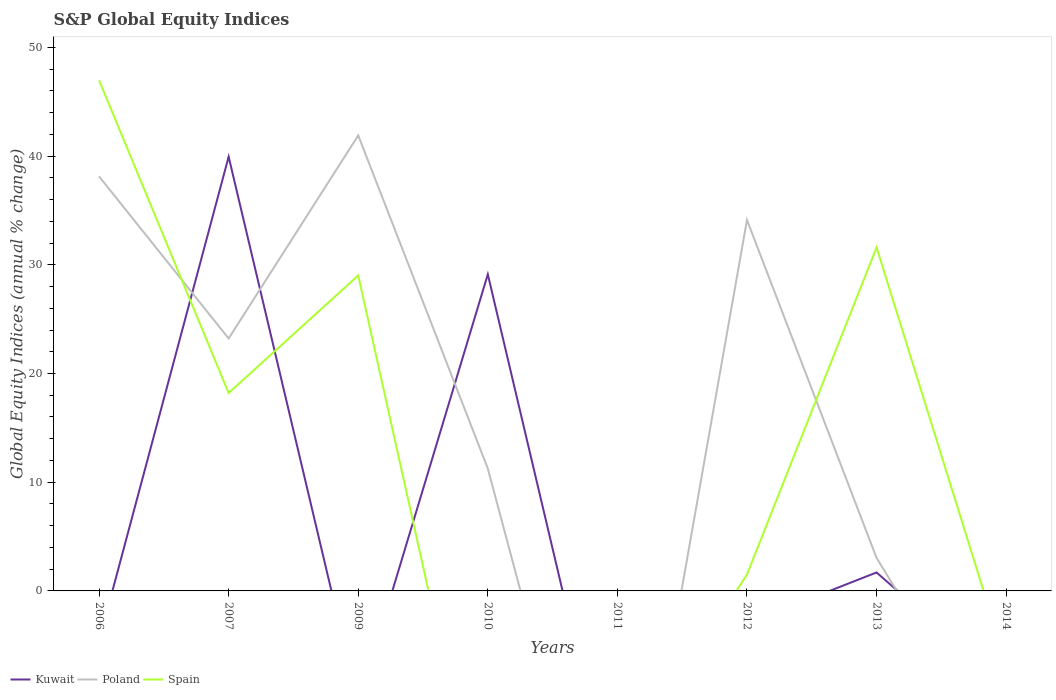Does the line corresponding to Spain intersect with the line corresponding to Poland?
Provide a succinct answer. Yes. What is the total global equity indices in Kuwait in the graph?
Your answer should be very brief. 38.24. What is the difference between the highest and the second highest global equity indices in Spain?
Offer a terse response. 46.98. What is the difference between the highest and the lowest global equity indices in Spain?
Ensure brevity in your answer.  4. Is the global equity indices in Spain strictly greater than the global equity indices in Poland over the years?
Offer a terse response. No. How many lines are there?
Offer a terse response. 3. How many years are there in the graph?
Make the answer very short. 8. Are the values on the major ticks of Y-axis written in scientific E-notation?
Make the answer very short. No. Does the graph contain any zero values?
Your answer should be compact. Yes. What is the title of the graph?
Keep it short and to the point. S&P Global Equity Indices. Does "Latin America(developing only)" appear as one of the legend labels in the graph?
Make the answer very short. No. What is the label or title of the X-axis?
Offer a terse response. Years. What is the label or title of the Y-axis?
Offer a very short reply. Global Equity Indices (annual % change). What is the Global Equity Indices (annual % change) in Poland in 2006?
Ensure brevity in your answer.  38.13. What is the Global Equity Indices (annual % change) in Spain in 2006?
Your answer should be very brief. 46.98. What is the Global Equity Indices (annual % change) of Kuwait in 2007?
Ensure brevity in your answer.  39.94. What is the Global Equity Indices (annual % change) in Poland in 2007?
Provide a succinct answer. 23.22. What is the Global Equity Indices (annual % change) in Spain in 2007?
Your response must be concise. 18.21. What is the Global Equity Indices (annual % change) of Kuwait in 2009?
Offer a terse response. 0. What is the Global Equity Indices (annual % change) of Poland in 2009?
Provide a short and direct response. 41.9. What is the Global Equity Indices (annual % change) of Spain in 2009?
Give a very brief answer. 29.02. What is the Global Equity Indices (annual % change) of Kuwait in 2010?
Make the answer very short. 29.12. What is the Global Equity Indices (annual % change) of Poland in 2010?
Keep it short and to the point. 11.26. What is the Global Equity Indices (annual % change) in Spain in 2010?
Your response must be concise. 0. What is the Global Equity Indices (annual % change) of Kuwait in 2011?
Ensure brevity in your answer.  0. What is the Global Equity Indices (annual % change) of Kuwait in 2012?
Your answer should be very brief. 0. What is the Global Equity Indices (annual % change) in Poland in 2012?
Your response must be concise. 34.12. What is the Global Equity Indices (annual % change) of Spain in 2012?
Provide a short and direct response. 1.5. What is the Global Equity Indices (annual % change) of Kuwait in 2013?
Provide a short and direct response. 1.7. What is the Global Equity Indices (annual % change) of Poland in 2013?
Make the answer very short. 3.04. What is the Global Equity Indices (annual % change) in Spain in 2013?
Keep it short and to the point. 31.6. What is the Global Equity Indices (annual % change) of Kuwait in 2014?
Keep it short and to the point. 0. What is the Global Equity Indices (annual % change) of Poland in 2014?
Offer a terse response. 0. Across all years, what is the maximum Global Equity Indices (annual % change) of Kuwait?
Offer a very short reply. 39.94. Across all years, what is the maximum Global Equity Indices (annual % change) of Poland?
Make the answer very short. 41.9. Across all years, what is the maximum Global Equity Indices (annual % change) of Spain?
Provide a short and direct response. 46.98. Across all years, what is the minimum Global Equity Indices (annual % change) in Poland?
Provide a short and direct response. 0. Across all years, what is the minimum Global Equity Indices (annual % change) in Spain?
Your answer should be compact. 0. What is the total Global Equity Indices (annual % change) of Kuwait in the graph?
Offer a very short reply. 70.76. What is the total Global Equity Indices (annual % change) of Poland in the graph?
Ensure brevity in your answer.  151.67. What is the total Global Equity Indices (annual % change) in Spain in the graph?
Ensure brevity in your answer.  127.31. What is the difference between the Global Equity Indices (annual % change) in Poland in 2006 and that in 2007?
Provide a succinct answer. 14.91. What is the difference between the Global Equity Indices (annual % change) in Spain in 2006 and that in 2007?
Provide a short and direct response. 28.77. What is the difference between the Global Equity Indices (annual % change) in Poland in 2006 and that in 2009?
Provide a succinct answer. -3.77. What is the difference between the Global Equity Indices (annual % change) of Spain in 2006 and that in 2009?
Offer a terse response. 17.96. What is the difference between the Global Equity Indices (annual % change) in Poland in 2006 and that in 2010?
Your answer should be very brief. 26.87. What is the difference between the Global Equity Indices (annual % change) in Poland in 2006 and that in 2012?
Your answer should be compact. 4.01. What is the difference between the Global Equity Indices (annual % change) of Spain in 2006 and that in 2012?
Give a very brief answer. 45.47. What is the difference between the Global Equity Indices (annual % change) in Poland in 2006 and that in 2013?
Provide a short and direct response. 35.09. What is the difference between the Global Equity Indices (annual % change) in Spain in 2006 and that in 2013?
Offer a very short reply. 15.38. What is the difference between the Global Equity Indices (annual % change) of Poland in 2007 and that in 2009?
Ensure brevity in your answer.  -18.68. What is the difference between the Global Equity Indices (annual % change) in Spain in 2007 and that in 2009?
Offer a very short reply. -10.81. What is the difference between the Global Equity Indices (annual % change) of Kuwait in 2007 and that in 2010?
Offer a terse response. 10.81. What is the difference between the Global Equity Indices (annual % change) of Poland in 2007 and that in 2010?
Ensure brevity in your answer.  11.96. What is the difference between the Global Equity Indices (annual % change) of Poland in 2007 and that in 2012?
Give a very brief answer. -10.9. What is the difference between the Global Equity Indices (annual % change) in Spain in 2007 and that in 2012?
Give a very brief answer. 16.7. What is the difference between the Global Equity Indices (annual % change) of Kuwait in 2007 and that in 2013?
Offer a very short reply. 38.24. What is the difference between the Global Equity Indices (annual % change) of Poland in 2007 and that in 2013?
Give a very brief answer. 20.19. What is the difference between the Global Equity Indices (annual % change) in Spain in 2007 and that in 2013?
Offer a very short reply. -13.39. What is the difference between the Global Equity Indices (annual % change) in Poland in 2009 and that in 2010?
Ensure brevity in your answer.  30.64. What is the difference between the Global Equity Indices (annual % change) of Poland in 2009 and that in 2012?
Make the answer very short. 7.78. What is the difference between the Global Equity Indices (annual % change) in Spain in 2009 and that in 2012?
Your answer should be compact. 27.51. What is the difference between the Global Equity Indices (annual % change) of Poland in 2009 and that in 2013?
Keep it short and to the point. 38.86. What is the difference between the Global Equity Indices (annual % change) of Spain in 2009 and that in 2013?
Your response must be concise. -2.58. What is the difference between the Global Equity Indices (annual % change) in Poland in 2010 and that in 2012?
Make the answer very short. -22.86. What is the difference between the Global Equity Indices (annual % change) of Kuwait in 2010 and that in 2013?
Your answer should be compact. 27.43. What is the difference between the Global Equity Indices (annual % change) in Poland in 2010 and that in 2013?
Give a very brief answer. 8.22. What is the difference between the Global Equity Indices (annual % change) of Poland in 2012 and that in 2013?
Your response must be concise. 31.09. What is the difference between the Global Equity Indices (annual % change) in Spain in 2012 and that in 2013?
Your answer should be very brief. -30.1. What is the difference between the Global Equity Indices (annual % change) of Poland in 2006 and the Global Equity Indices (annual % change) of Spain in 2007?
Offer a very short reply. 19.92. What is the difference between the Global Equity Indices (annual % change) of Poland in 2006 and the Global Equity Indices (annual % change) of Spain in 2009?
Provide a succinct answer. 9.11. What is the difference between the Global Equity Indices (annual % change) of Poland in 2006 and the Global Equity Indices (annual % change) of Spain in 2012?
Ensure brevity in your answer.  36.63. What is the difference between the Global Equity Indices (annual % change) in Poland in 2006 and the Global Equity Indices (annual % change) in Spain in 2013?
Ensure brevity in your answer.  6.53. What is the difference between the Global Equity Indices (annual % change) of Kuwait in 2007 and the Global Equity Indices (annual % change) of Poland in 2009?
Offer a terse response. -1.96. What is the difference between the Global Equity Indices (annual % change) of Kuwait in 2007 and the Global Equity Indices (annual % change) of Spain in 2009?
Your answer should be compact. 10.92. What is the difference between the Global Equity Indices (annual % change) in Poland in 2007 and the Global Equity Indices (annual % change) in Spain in 2009?
Your answer should be compact. -5.8. What is the difference between the Global Equity Indices (annual % change) of Kuwait in 2007 and the Global Equity Indices (annual % change) of Poland in 2010?
Give a very brief answer. 28.68. What is the difference between the Global Equity Indices (annual % change) of Kuwait in 2007 and the Global Equity Indices (annual % change) of Poland in 2012?
Ensure brevity in your answer.  5.82. What is the difference between the Global Equity Indices (annual % change) in Kuwait in 2007 and the Global Equity Indices (annual % change) in Spain in 2012?
Ensure brevity in your answer.  38.44. What is the difference between the Global Equity Indices (annual % change) in Poland in 2007 and the Global Equity Indices (annual % change) in Spain in 2012?
Ensure brevity in your answer.  21.72. What is the difference between the Global Equity Indices (annual % change) of Kuwait in 2007 and the Global Equity Indices (annual % change) of Poland in 2013?
Your answer should be compact. 36.9. What is the difference between the Global Equity Indices (annual % change) of Kuwait in 2007 and the Global Equity Indices (annual % change) of Spain in 2013?
Provide a succinct answer. 8.34. What is the difference between the Global Equity Indices (annual % change) in Poland in 2007 and the Global Equity Indices (annual % change) in Spain in 2013?
Give a very brief answer. -8.38. What is the difference between the Global Equity Indices (annual % change) of Poland in 2009 and the Global Equity Indices (annual % change) of Spain in 2012?
Give a very brief answer. 40.4. What is the difference between the Global Equity Indices (annual % change) of Poland in 2009 and the Global Equity Indices (annual % change) of Spain in 2013?
Offer a very short reply. 10.3. What is the difference between the Global Equity Indices (annual % change) in Kuwait in 2010 and the Global Equity Indices (annual % change) in Poland in 2012?
Offer a terse response. -5. What is the difference between the Global Equity Indices (annual % change) of Kuwait in 2010 and the Global Equity Indices (annual % change) of Spain in 2012?
Your answer should be very brief. 27.62. What is the difference between the Global Equity Indices (annual % change) in Poland in 2010 and the Global Equity Indices (annual % change) in Spain in 2012?
Give a very brief answer. 9.76. What is the difference between the Global Equity Indices (annual % change) in Kuwait in 2010 and the Global Equity Indices (annual % change) in Poland in 2013?
Offer a very short reply. 26.09. What is the difference between the Global Equity Indices (annual % change) in Kuwait in 2010 and the Global Equity Indices (annual % change) in Spain in 2013?
Your answer should be compact. -2.48. What is the difference between the Global Equity Indices (annual % change) in Poland in 2010 and the Global Equity Indices (annual % change) in Spain in 2013?
Ensure brevity in your answer.  -20.34. What is the difference between the Global Equity Indices (annual % change) of Poland in 2012 and the Global Equity Indices (annual % change) of Spain in 2013?
Keep it short and to the point. 2.52. What is the average Global Equity Indices (annual % change) in Kuwait per year?
Your answer should be compact. 8.85. What is the average Global Equity Indices (annual % change) of Poland per year?
Provide a succinct answer. 18.96. What is the average Global Equity Indices (annual % change) of Spain per year?
Keep it short and to the point. 15.91. In the year 2006, what is the difference between the Global Equity Indices (annual % change) of Poland and Global Equity Indices (annual % change) of Spain?
Your response must be concise. -8.85. In the year 2007, what is the difference between the Global Equity Indices (annual % change) of Kuwait and Global Equity Indices (annual % change) of Poland?
Your answer should be compact. 16.72. In the year 2007, what is the difference between the Global Equity Indices (annual % change) of Kuwait and Global Equity Indices (annual % change) of Spain?
Provide a short and direct response. 21.73. In the year 2007, what is the difference between the Global Equity Indices (annual % change) of Poland and Global Equity Indices (annual % change) of Spain?
Your answer should be compact. 5.01. In the year 2009, what is the difference between the Global Equity Indices (annual % change) in Poland and Global Equity Indices (annual % change) in Spain?
Give a very brief answer. 12.88. In the year 2010, what is the difference between the Global Equity Indices (annual % change) in Kuwait and Global Equity Indices (annual % change) in Poland?
Offer a very short reply. 17.86. In the year 2012, what is the difference between the Global Equity Indices (annual % change) of Poland and Global Equity Indices (annual % change) of Spain?
Your response must be concise. 32.62. In the year 2013, what is the difference between the Global Equity Indices (annual % change) in Kuwait and Global Equity Indices (annual % change) in Poland?
Your response must be concise. -1.34. In the year 2013, what is the difference between the Global Equity Indices (annual % change) of Kuwait and Global Equity Indices (annual % change) of Spain?
Ensure brevity in your answer.  -29.9. In the year 2013, what is the difference between the Global Equity Indices (annual % change) in Poland and Global Equity Indices (annual % change) in Spain?
Give a very brief answer. -28.56. What is the ratio of the Global Equity Indices (annual % change) of Poland in 2006 to that in 2007?
Offer a very short reply. 1.64. What is the ratio of the Global Equity Indices (annual % change) of Spain in 2006 to that in 2007?
Give a very brief answer. 2.58. What is the ratio of the Global Equity Indices (annual % change) of Poland in 2006 to that in 2009?
Ensure brevity in your answer.  0.91. What is the ratio of the Global Equity Indices (annual % change) in Spain in 2006 to that in 2009?
Provide a succinct answer. 1.62. What is the ratio of the Global Equity Indices (annual % change) of Poland in 2006 to that in 2010?
Your answer should be very brief. 3.39. What is the ratio of the Global Equity Indices (annual % change) of Poland in 2006 to that in 2012?
Give a very brief answer. 1.12. What is the ratio of the Global Equity Indices (annual % change) of Spain in 2006 to that in 2012?
Keep it short and to the point. 31.24. What is the ratio of the Global Equity Indices (annual % change) of Poland in 2006 to that in 2013?
Provide a succinct answer. 12.56. What is the ratio of the Global Equity Indices (annual % change) in Spain in 2006 to that in 2013?
Offer a very short reply. 1.49. What is the ratio of the Global Equity Indices (annual % change) in Poland in 2007 to that in 2009?
Your answer should be compact. 0.55. What is the ratio of the Global Equity Indices (annual % change) of Spain in 2007 to that in 2009?
Your answer should be very brief. 0.63. What is the ratio of the Global Equity Indices (annual % change) of Kuwait in 2007 to that in 2010?
Provide a short and direct response. 1.37. What is the ratio of the Global Equity Indices (annual % change) in Poland in 2007 to that in 2010?
Your response must be concise. 2.06. What is the ratio of the Global Equity Indices (annual % change) in Poland in 2007 to that in 2012?
Your response must be concise. 0.68. What is the ratio of the Global Equity Indices (annual % change) of Spain in 2007 to that in 2012?
Make the answer very short. 12.11. What is the ratio of the Global Equity Indices (annual % change) of Kuwait in 2007 to that in 2013?
Keep it short and to the point. 23.51. What is the ratio of the Global Equity Indices (annual % change) in Poland in 2007 to that in 2013?
Keep it short and to the point. 7.65. What is the ratio of the Global Equity Indices (annual % change) in Spain in 2007 to that in 2013?
Your answer should be very brief. 0.58. What is the ratio of the Global Equity Indices (annual % change) in Poland in 2009 to that in 2010?
Your answer should be very brief. 3.72. What is the ratio of the Global Equity Indices (annual % change) in Poland in 2009 to that in 2012?
Provide a succinct answer. 1.23. What is the ratio of the Global Equity Indices (annual % change) in Spain in 2009 to that in 2012?
Your response must be concise. 19.3. What is the ratio of the Global Equity Indices (annual % change) in Poland in 2009 to that in 2013?
Give a very brief answer. 13.8. What is the ratio of the Global Equity Indices (annual % change) in Spain in 2009 to that in 2013?
Ensure brevity in your answer.  0.92. What is the ratio of the Global Equity Indices (annual % change) in Poland in 2010 to that in 2012?
Your answer should be compact. 0.33. What is the ratio of the Global Equity Indices (annual % change) in Kuwait in 2010 to that in 2013?
Keep it short and to the point. 17.15. What is the ratio of the Global Equity Indices (annual % change) in Poland in 2010 to that in 2013?
Give a very brief answer. 3.71. What is the ratio of the Global Equity Indices (annual % change) of Poland in 2012 to that in 2013?
Make the answer very short. 11.24. What is the ratio of the Global Equity Indices (annual % change) in Spain in 2012 to that in 2013?
Ensure brevity in your answer.  0.05. What is the difference between the highest and the second highest Global Equity Indices (annual % change) of Kuwait?
Your response must be concise. 10.81. What is the difference between the highest and the second highest Global Equity Indices (annual % change) of Poland?
Provide a short and direct response. 3.77. What is the difference between the highest and the second highest Global Equity Indices (annual % change) of Spain?
Your answer should be very brief. 15.38. What is the difference between the highest and the lowest Global Equity Indices (annual % change) in Kuwait?
Your answer should be compact. 39.94. What is the difference between the highest and the lowest Global Equity Indices (annual % change) in Poland?
Offer a very short reply. 41.9. What is the difference between the highest and the lowest Global Equity Indices (annual % change) of Spain?
Provide a short and direct response. 46.98. 